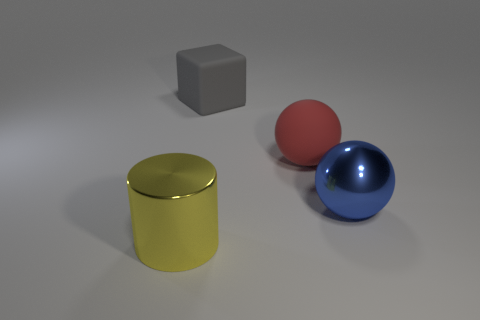Does the big red thing have the same shape as the shiny thing to the left of the gray object?
Offer a terse response. No. Is the number of red spheres greater than the number of small red cylinders?
Your answer should be compact. Yes. There is a big shiny object to the right of the gray object; does it have the same shape as the big red object?
Offer a very short reply. Yes. Is the number of large gray rubber things left of the red thing greater than the number of green cylinders?
Offer a very short reply. Yes. What is the color of the large metallic object in front of the metallic thing to the right of the metallic cylinder?
Keep it short and to the point. Yellow. How many things are there?
Offer a very short reply. 4. How many objects are behind the metallic sphere and left of the large red matte thing?
Make the answer very short. 1. Is there any other thing that has the same shape as the gray rubber thing?
Offer a terse response. No. What shape is the metallic object in front of the big shiny sphere?
Provide a succinct answer. Cylinder. What number of other objects are there of the same material as the big yellow object?
Provide a short and direct response. 1. 